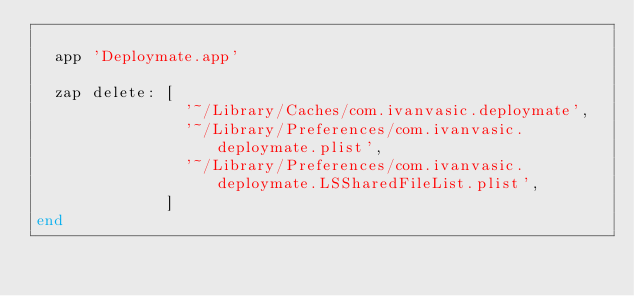<code> <loc_0><loc_0><loc_500><loc_500><_Ruby_>
  app 'Deploymate.app'

  zap delete: [
                '~/Library/Caches/com.ivanvasic.deploymate',
                '~/Library/Preferences/com.ivanvasic.deploymate.plist',
                '~/Library/Preferences/com.ivanvasic.deploymate.LSSharedFileList.plist',
              ]
end
</code> 